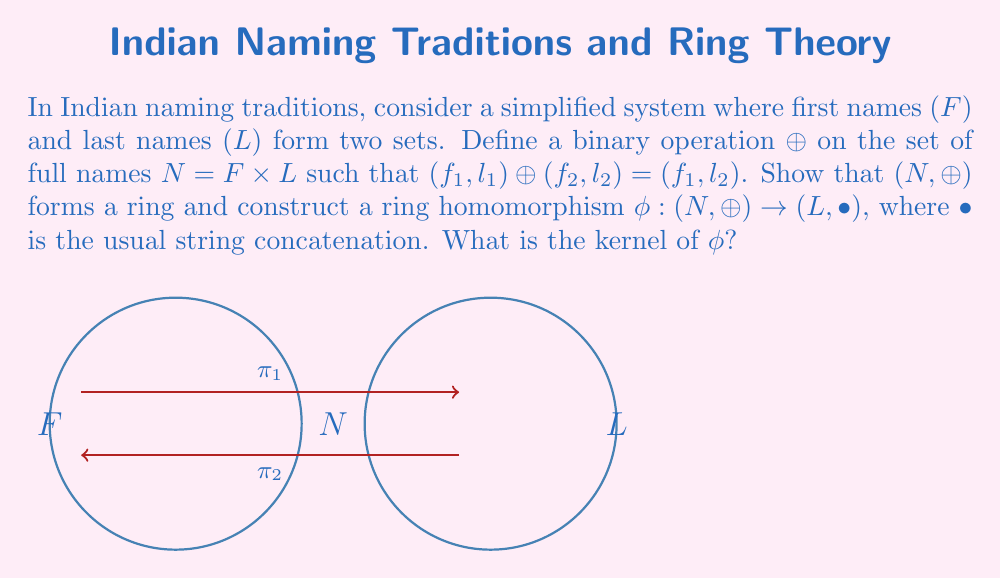Teach me how to tackle this problem. 1. First, let's verify that (N, ⊕) is a ring:

   a) (N, ⊕) is an abelian group:
      - Closure: For any (f₁, l₁), (f₂, l₂) ∈ N, (f₁, l₁) ⊕ (f₂, l₂) = (f₁, l₂) ∈ N
      - Associativity: ((f₁, l₁) ⊕ (f₂, l₂)) ⊕ (f₃, l₃) = (f₁, l₂) ⊕ (f₃, l₃) = (f₁, l₃)
                       (f₁, l₁) ⊕ ((f₂, l₂) ⊕ (f₃, l₃)) = (f₁, l₁) ⊕ (f₂, l₃) = (f₁, l₃)
      - Identity: (f, l) ⊕ (f, l) = (f, l) for any (f, l) ∈ N
      - Inverse: Each element is its own inverse
      - Commutativity: (f₁, l₁) ⊕ (f₂, l₂) = (f₁, l₂) = (f₂, l₁) = (f₂, l₂) ⊕ (f₁, l₁)

   b) (N, ⊕) has distributive laws:
      ((f₁, l₁) ⊕ (f₂, l₂)) ⊕ (f₃, l₃) = (f₁, l₂) ⊕ (f₃, l₃) = (f₁, l₃)
      ((f₁, l₁) ⊕ (f₃, l₃)) ⊕ ((f₂, l₂) ⊕ (f₃, l₃)) = (f₁, l₃) ⊕ (f₂, l₃) = (f₁, l₃)

2. Now, let's construct the ring homomorphism φ : (N, ⊕) → (L, •):
   Define φ((f, l)) = l for all (f, l) ∈ N

3. To verify that φ is a ring homomorphism:
   φ((f₁, l₁) ⊕ (f₂, l₂)) = φ((f₁, l₂)) = l₂
   φ((f₁, l₁)) • φ((f₂, l₂)) = l₁ • l₂ = l₂ (since • is defined as string concatenation)

4. The kernel of φ is:
   ker(φ) = {(f, l) ∈ N | φ((f, l)) = e_L}, where e_L is the identity element in L
   Since the identity element for string concatenation is the empty string, 
   ker(φ) = {(f, "") | f ∈ F}, where "" represents the empty string
Answer: $\text{ker}(\phi) = \{(f, "") | f \in F\}$ 